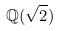Convert formula to latex. <formula><loc_0><loc_0><loc_500><loc_500>\mathbb { Q } ( \sqrt { 2 } )</formula> 